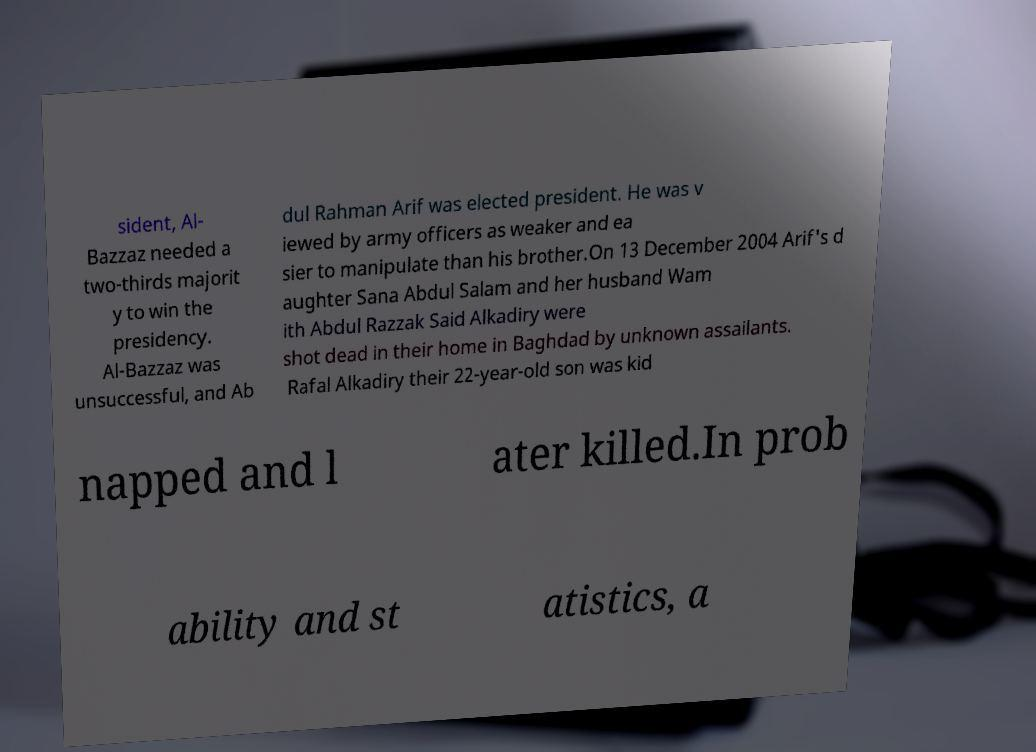For documentation purposes, I need the text within this image transcribed. Could you provide that? sident, Al- Bazzaz needed a two-thirds majorit y to win the presidency. Al-Bazzaz was unsuccessful, and Ab dul Rahman Arif was elected president. He was v iewed by army officers as weaker and ea sier to manipulate than his brother.On 13 December 2004 Arif's d aughter Sana Abdul Salam and her husband Wam ith Abdul Razzak Said Alkadiry were shot dead in their home in Baghdad by unknown assailants. Rafal Alkadiry their 22-year-old son was kid napped and l ater killed.In prob ability and st atistics, a 